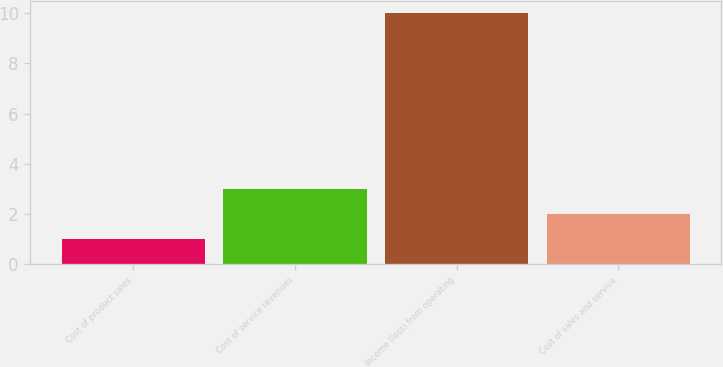<chart> <loc_0><loc_0><loc_500><loc_500><bar_chart><fcel>Cost of product sales<fcel>Cost of service revenues<fcel>Income (loss) from operating<fcel>Cost of sales and service<nl><fcel>1<fcel>3<fcel>10<fcel>2<nl></chart> 